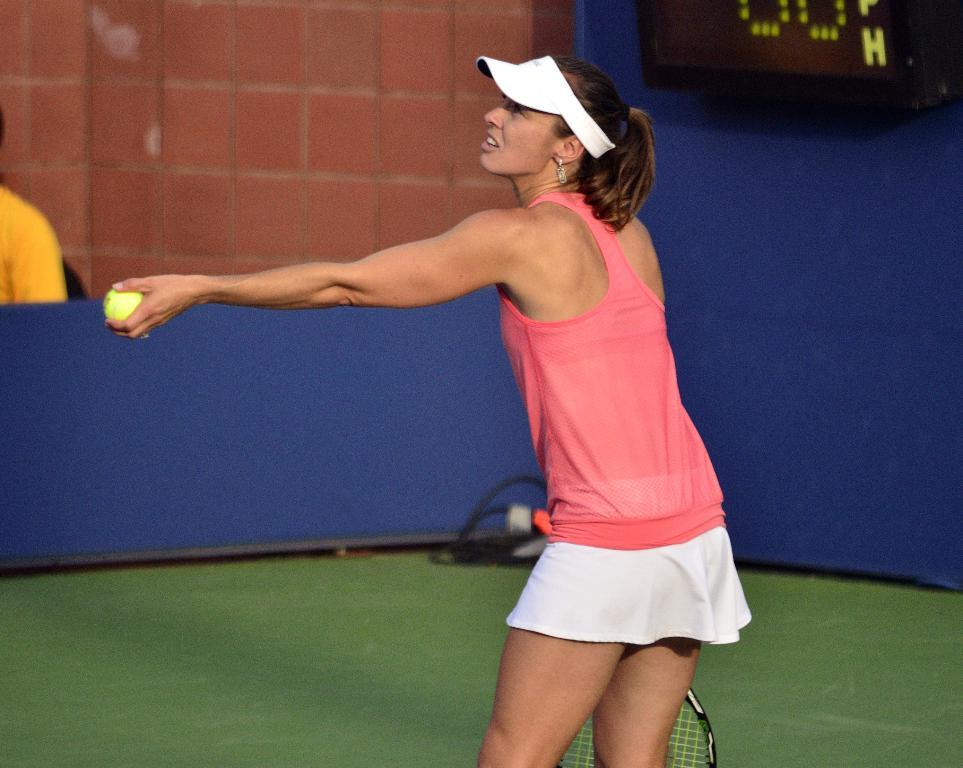Who is present in the image? There is a woman in the image. What is the woman wearing? The woman is wearing a pink dress. What is the woman holding in her hands? The woman is holding a tennis racket and a tennis ball. What type of sheet is the woman using to play tennis in the image? There is no sheet present in the image, and the woman is not playing tennis. 